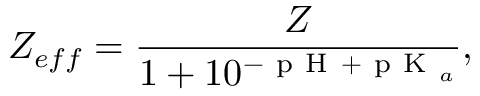<formula> <loc_0><loc_0><loc_500><loc_500>Z _ { e f f } = \frac { Z } { 1 + 1 0 ^ { - p H + p K _ { a } } } ,</formula> 